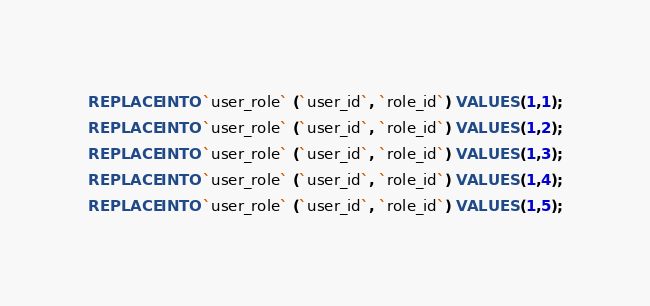Convert code to text. <code><loc_0><loc_0><loc_500><loc_500><_SQL_>REPLACE INTO `user_role` (`user_id`, `role_id`) VALUES (1,1);
REPLACE INTO `user_role` (`user_id`, `role_id`) VALUES (1,2);
REPLACE INTO `user_role` (`user_id`, `role_id`) VALUES (1,3);
REPLACE INTO `user_role` (`user_id`, `role_id`) VALUES (1,4);
REPLACE INTO `user_role` (`user_id`, `role_id`) VALUES (1,5);
</code> 